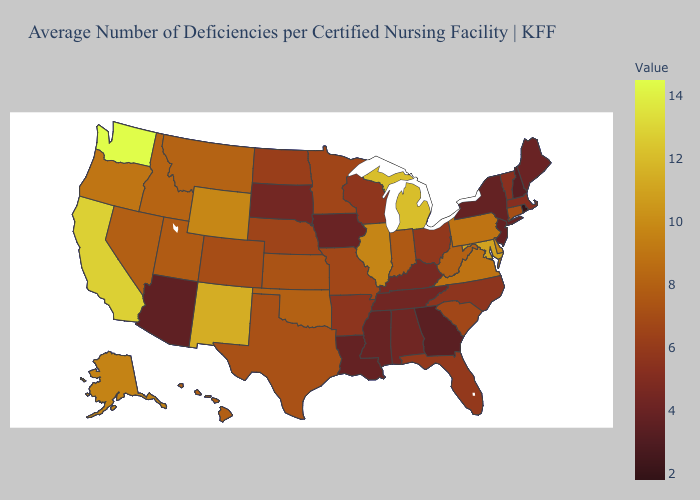Does Rhode Island have the lowest value in the Northeast?
Concise answer only. Yes. Which states hav the highest value in the South?
Write a very short answer. Maryland. Is the legend a continuous bar?
Quick response, please. Yes. Which states have the lowest value in the USA?
Short answer required. Rhode Island. 